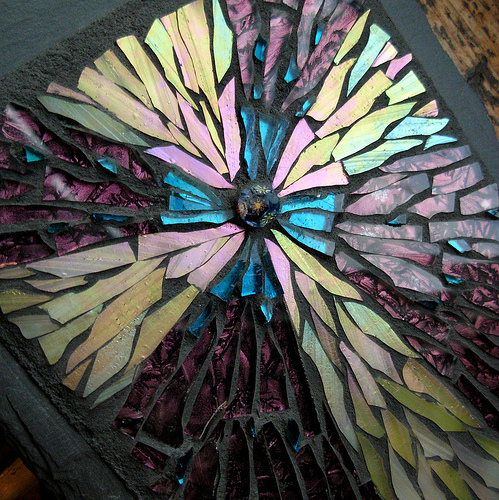<image>
Is there a pebble above the frame? No. The pebble is not positioned above the frame. The vertical arrangement shows a different relationship. 